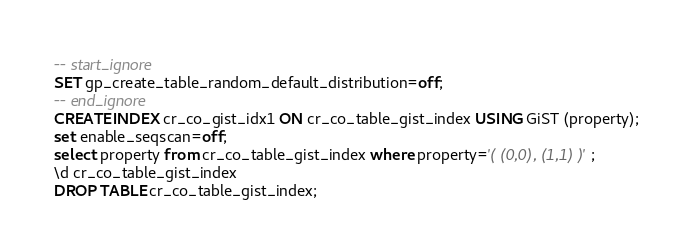Convert code to text. <code><loc_0><loc_0><loc_500><loc_500><_SQL_>-- start_ignore
SET gp_create_table_random_default_distribution=off;
-- end_ignore
CREATE INDEX cr_co_gist_idx1 ON cr_co_table_gist_index USING GiST (property);
set enable_seqscan=off;
select property from cr_co_table_gist_index where property='( (0,0), (1,1) )';
\d cr_co_table_gist_index
DROP TABLE cr_co_table_gist_index;
</code> 